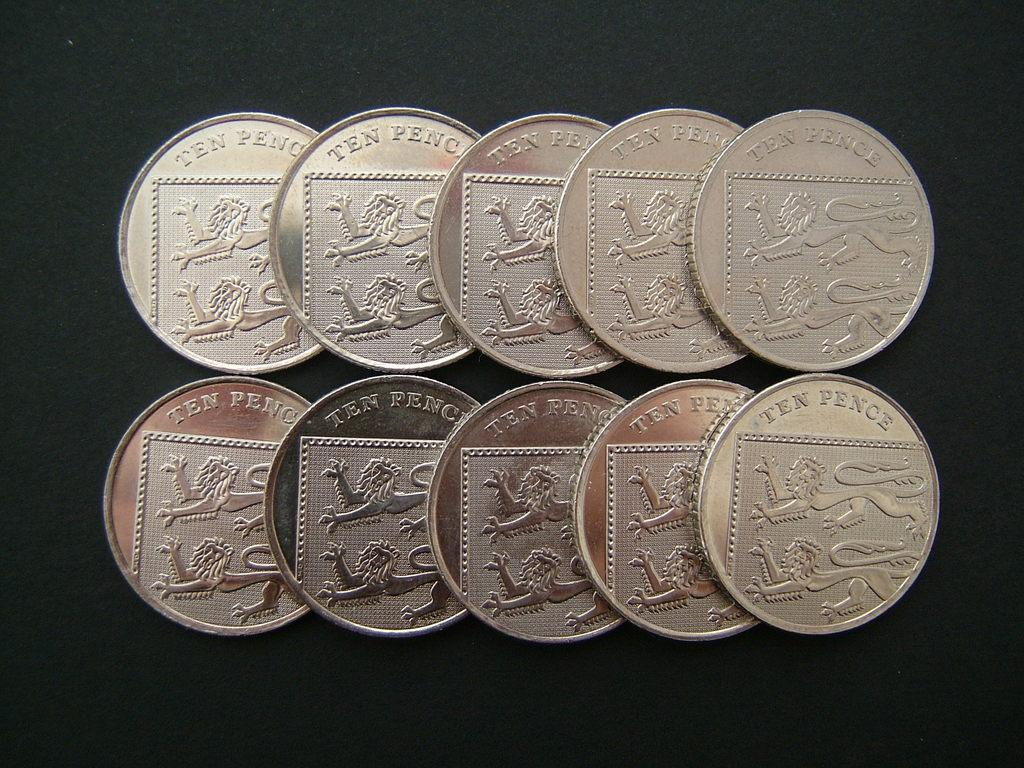<image>
Give a short and clear explanation of the subsequent image. Two rows of five ten pence pieces are laid out. 